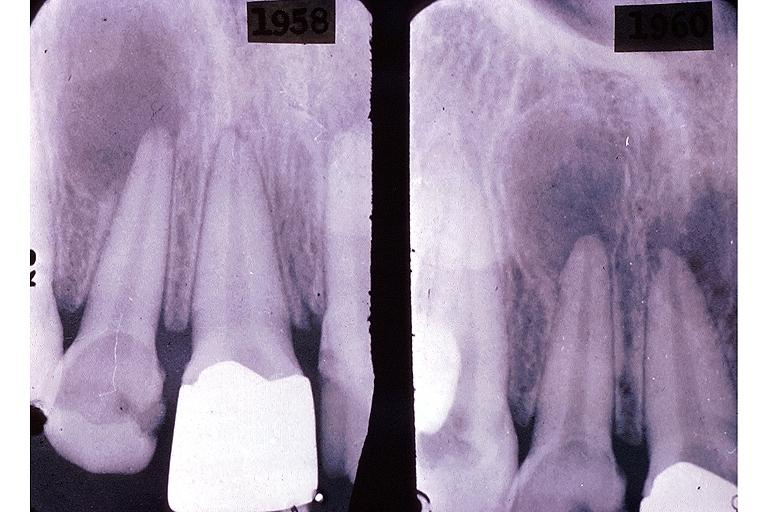s oral present?
Answer the question using a single word or phrase. Yes 